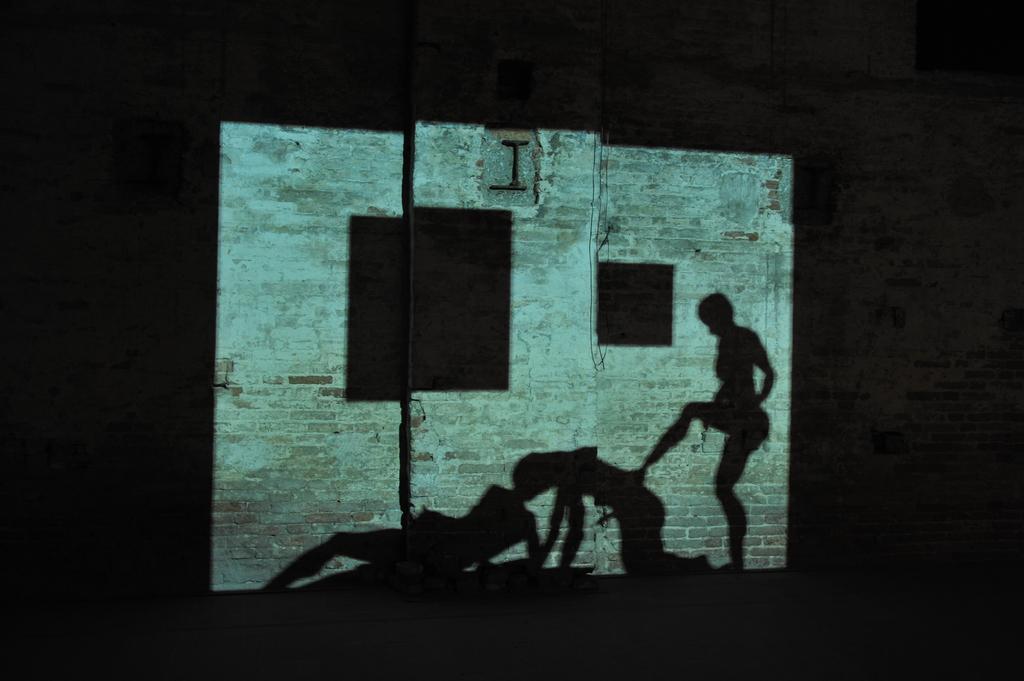Can you describe this image briefly? In the center of the image there is a screen in which there are reflections of the people. In the background of the image there is a wall. 